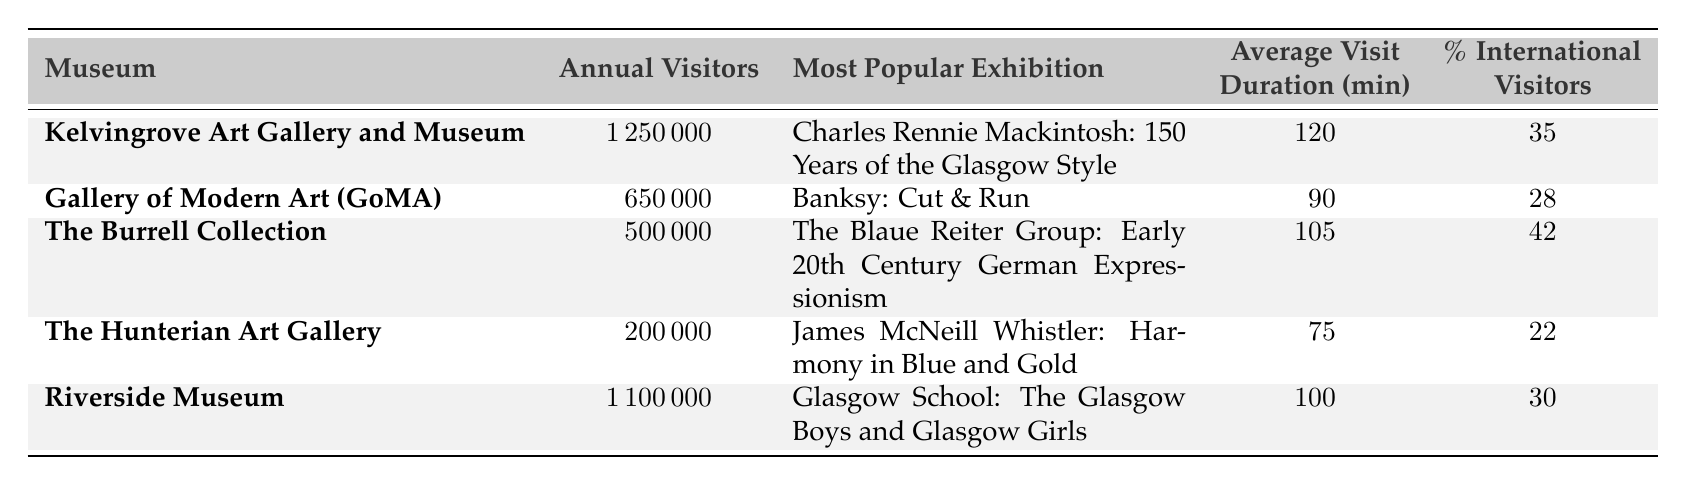What is the annual visitor count for the Kelvingrove Art Gallery and Museum? The table shows "Annual Visitors" for each museum. For the Kelvingrove Art Gallery and Museum, the corresponding value under "Annual Visitors" is 1,250,000.
Answer: 1,250,000 Which museum had the most international visitors percentage? The table lists the percentage of international visitors for each museum. The Burrell Collection has the highest percentage at 42%.
Answer: 42% What is the average visit duration for the Gallery of Modern Art (GoMA)? The "Average Visit Duration" column indicates that for the Gallery of Modern Art (GoMA), the average visit duration is 90 minutes.
Answer: 90 minutes How many total annual visitors do the Riverside Museum and The Hunterian Art Gallery attract combined? We need to sum the annual visitors from the Riverside Museum (1,100,000) and The Hunterian Art Gallery (200,000), resulting in 1,100,000 + 200,000 = 1,300,000.
Answer: 1,300,000 Is the average visit duration for The Burrell Collection greater than that of the Hunterian Art Gallery? The average visit duration for The Burrell Collection is 105 minutes, while that of The Hunterian Art Gallery is 75 minutes, which confirms that The Burrell Collection has a greater average visit duration.
Answer: Yes Which museum's most popular exhibition is dedicated to James McNeill Whistler? The table indicates that the most popular exhibition at The Hunterian Art Gallery is dedicated to James McNeill Whistler, specifically titled "Harmony in Blue and Gold."
Answer: The Hunterian Art Gallery If we consider only the top two museums by visitor count, what is their average percentage of international visitors? To find the average percentage of international visitors for the top two museums, we take Kelvingrove Art Gallery and Museum (35%) and Riverside Museum (30%). The average is calculated as (35 + 30) / 2 = 32.5%.
Answer: 32.5% Which museum had the least annual visitors, and what was that count? The table shows that The Hunterian Art Gallery had the least annual visitors, with a count of 200,000.
Answer: 200,000 What is the difference in annual visitors between the most visited museum and the least visited one? The most visited museum is the Kelvingrove Art Gallery and Museum with 1,250,000 annual visitors, while the least visited is The Hunterian Art Gallery with 200,000. The difference is 1,250,000 - 200,000 = 1,050,000.
Answer: 1,050,000 